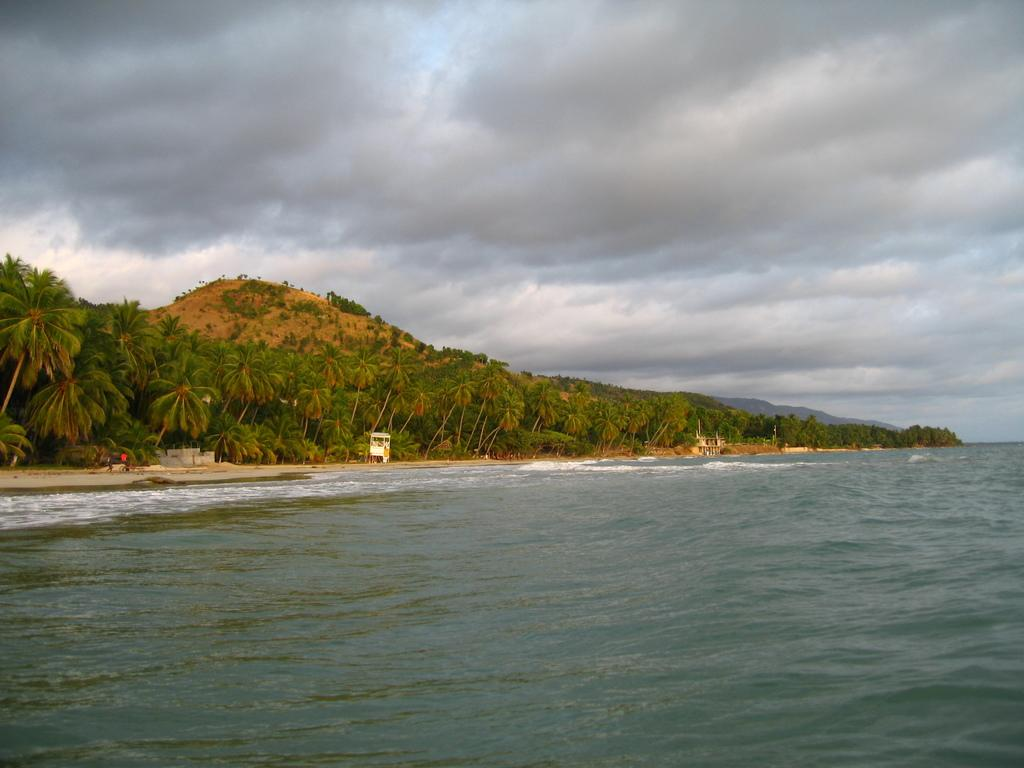What is the primary element visible in the image? There is water in the image. What type of vegetation can be seen in the image? There are trees in the image. What is the condition of the sky in the background of the image? The sky is cloudy in the background of the image. Can you see a zipper on any of the trees in the image? There is no zipper present on any of the trees in the image. What thoughts might the water be having in the image? The water is an inanimate object and cannot have thoughts. 